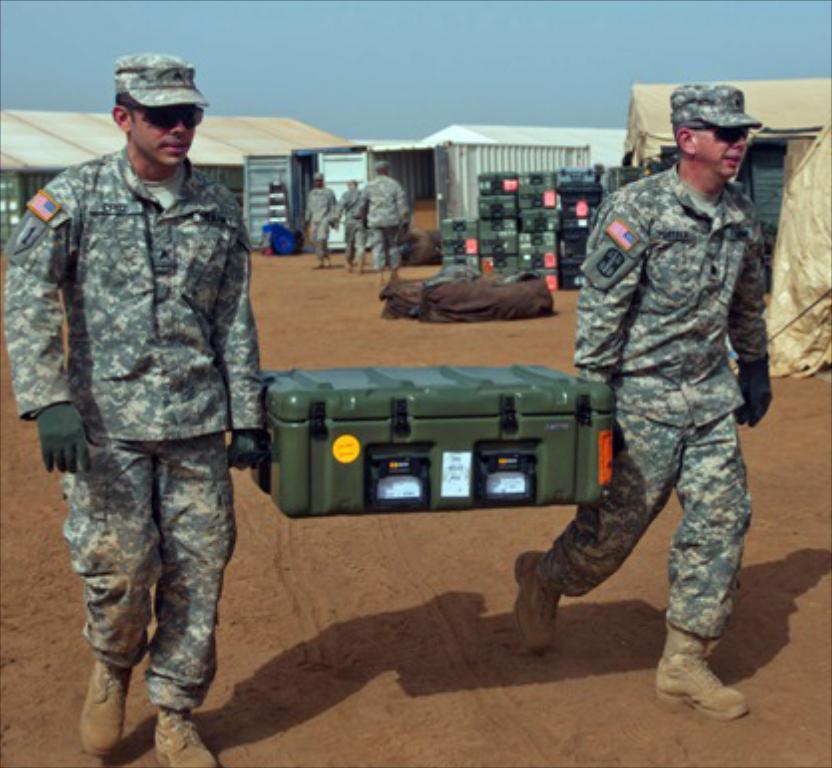How would you summarize this image in a sentence or two? There are two soldiers wearing cap, goggles and gloves is holding a box. In the back there are sheds, boxes and people. In the background there is sky. 